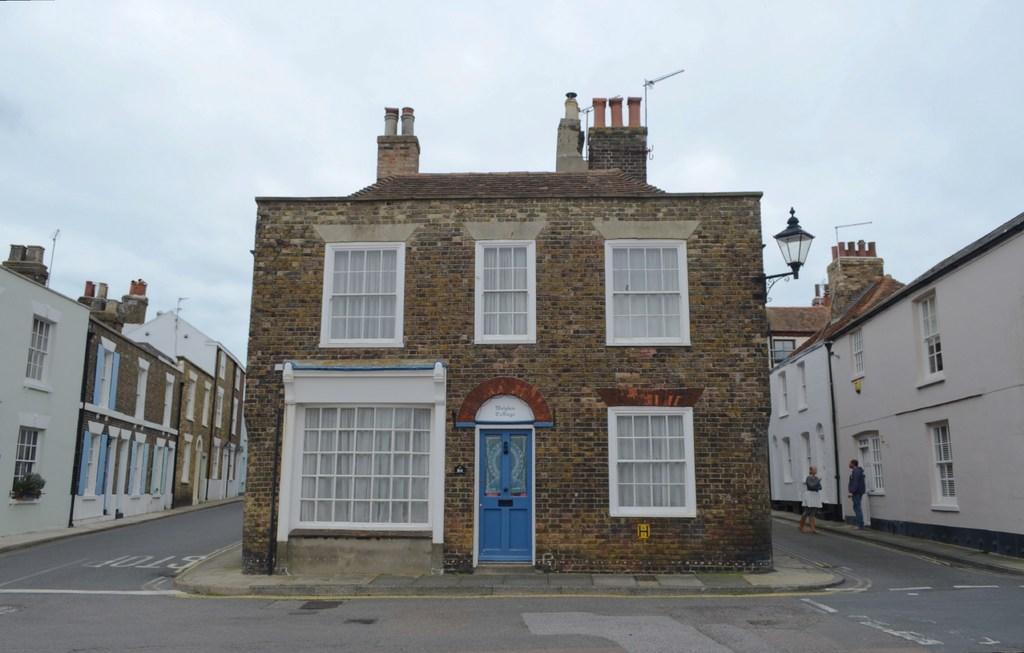Could you give a brief overview of what you see in this image? In this image there are three different buildings beside the road also there are two people standing beside the building. 